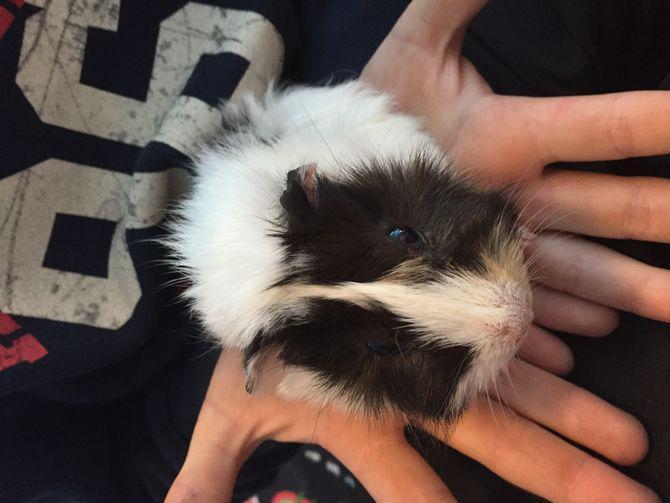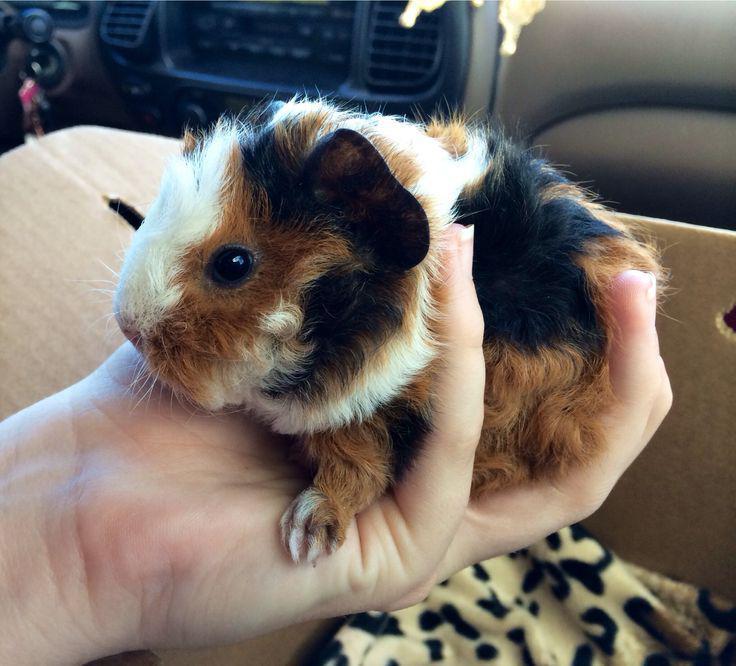The first image is the image on the left, the second image is the image on the right. Evaluate the accuracy of this statement regarding the images: "Each image shows a guinea pigs held in an upturned palm of at least one hand.". Is it true? Answer yes or no. Yes. The first image is the image on the left, the second image is the image on the right. Assess this claim about the two images: "There is a guinea pig in the right image looking towards the right.". Correct or not? Answer yes or no. No. 